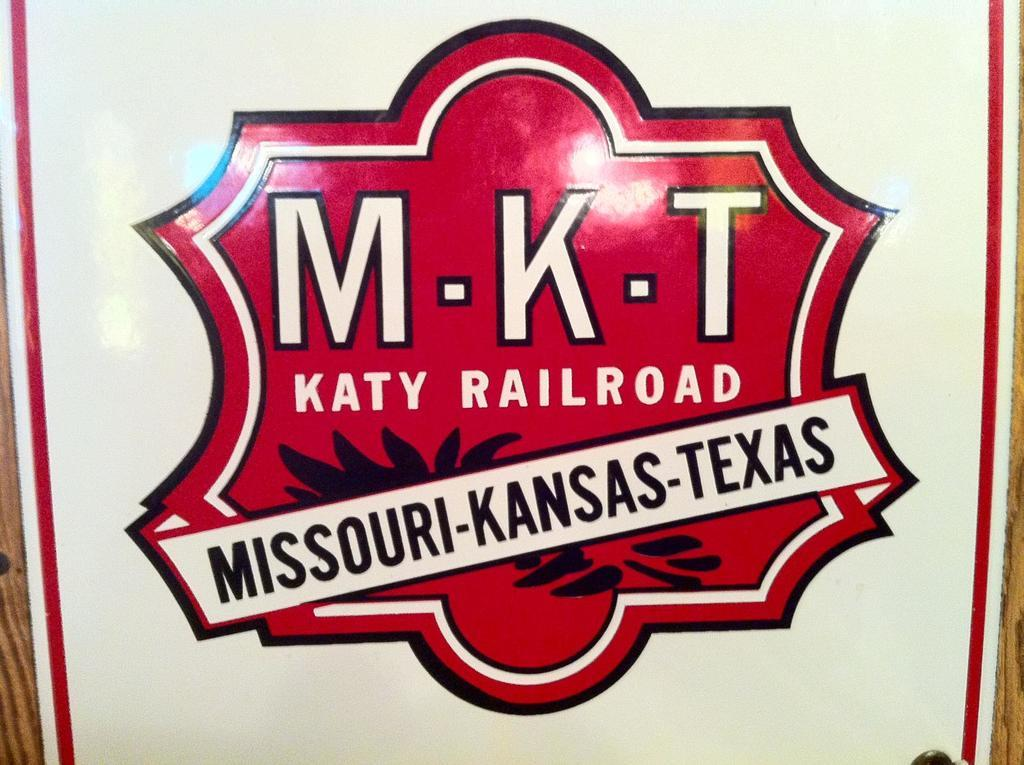<image>
Share a concise interpretation of the image provided. The logo of the M-K-T Katy Railroad in Missouri, Kansas, and Texas. 